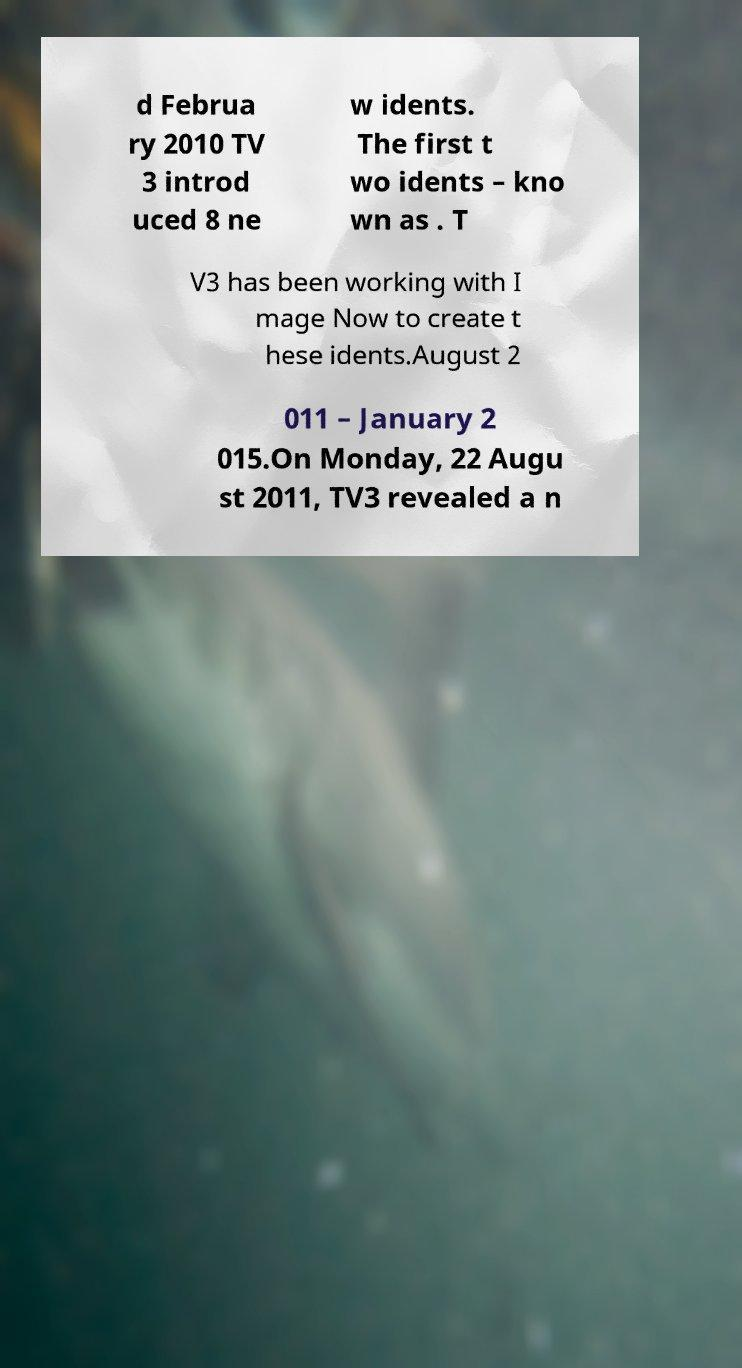For documentation purposes, I need the text within this image transcribed. Could you provide that? d Februa ry 2010 TV 3 introd uced 8 ne w idents. The first t wo idents – kno wn as . T V3 has been working with I mage Now to create t hese idents.August 2 011 – January 2 015.On Monday, 22 Augu st 2011, TV3 revealed a n 